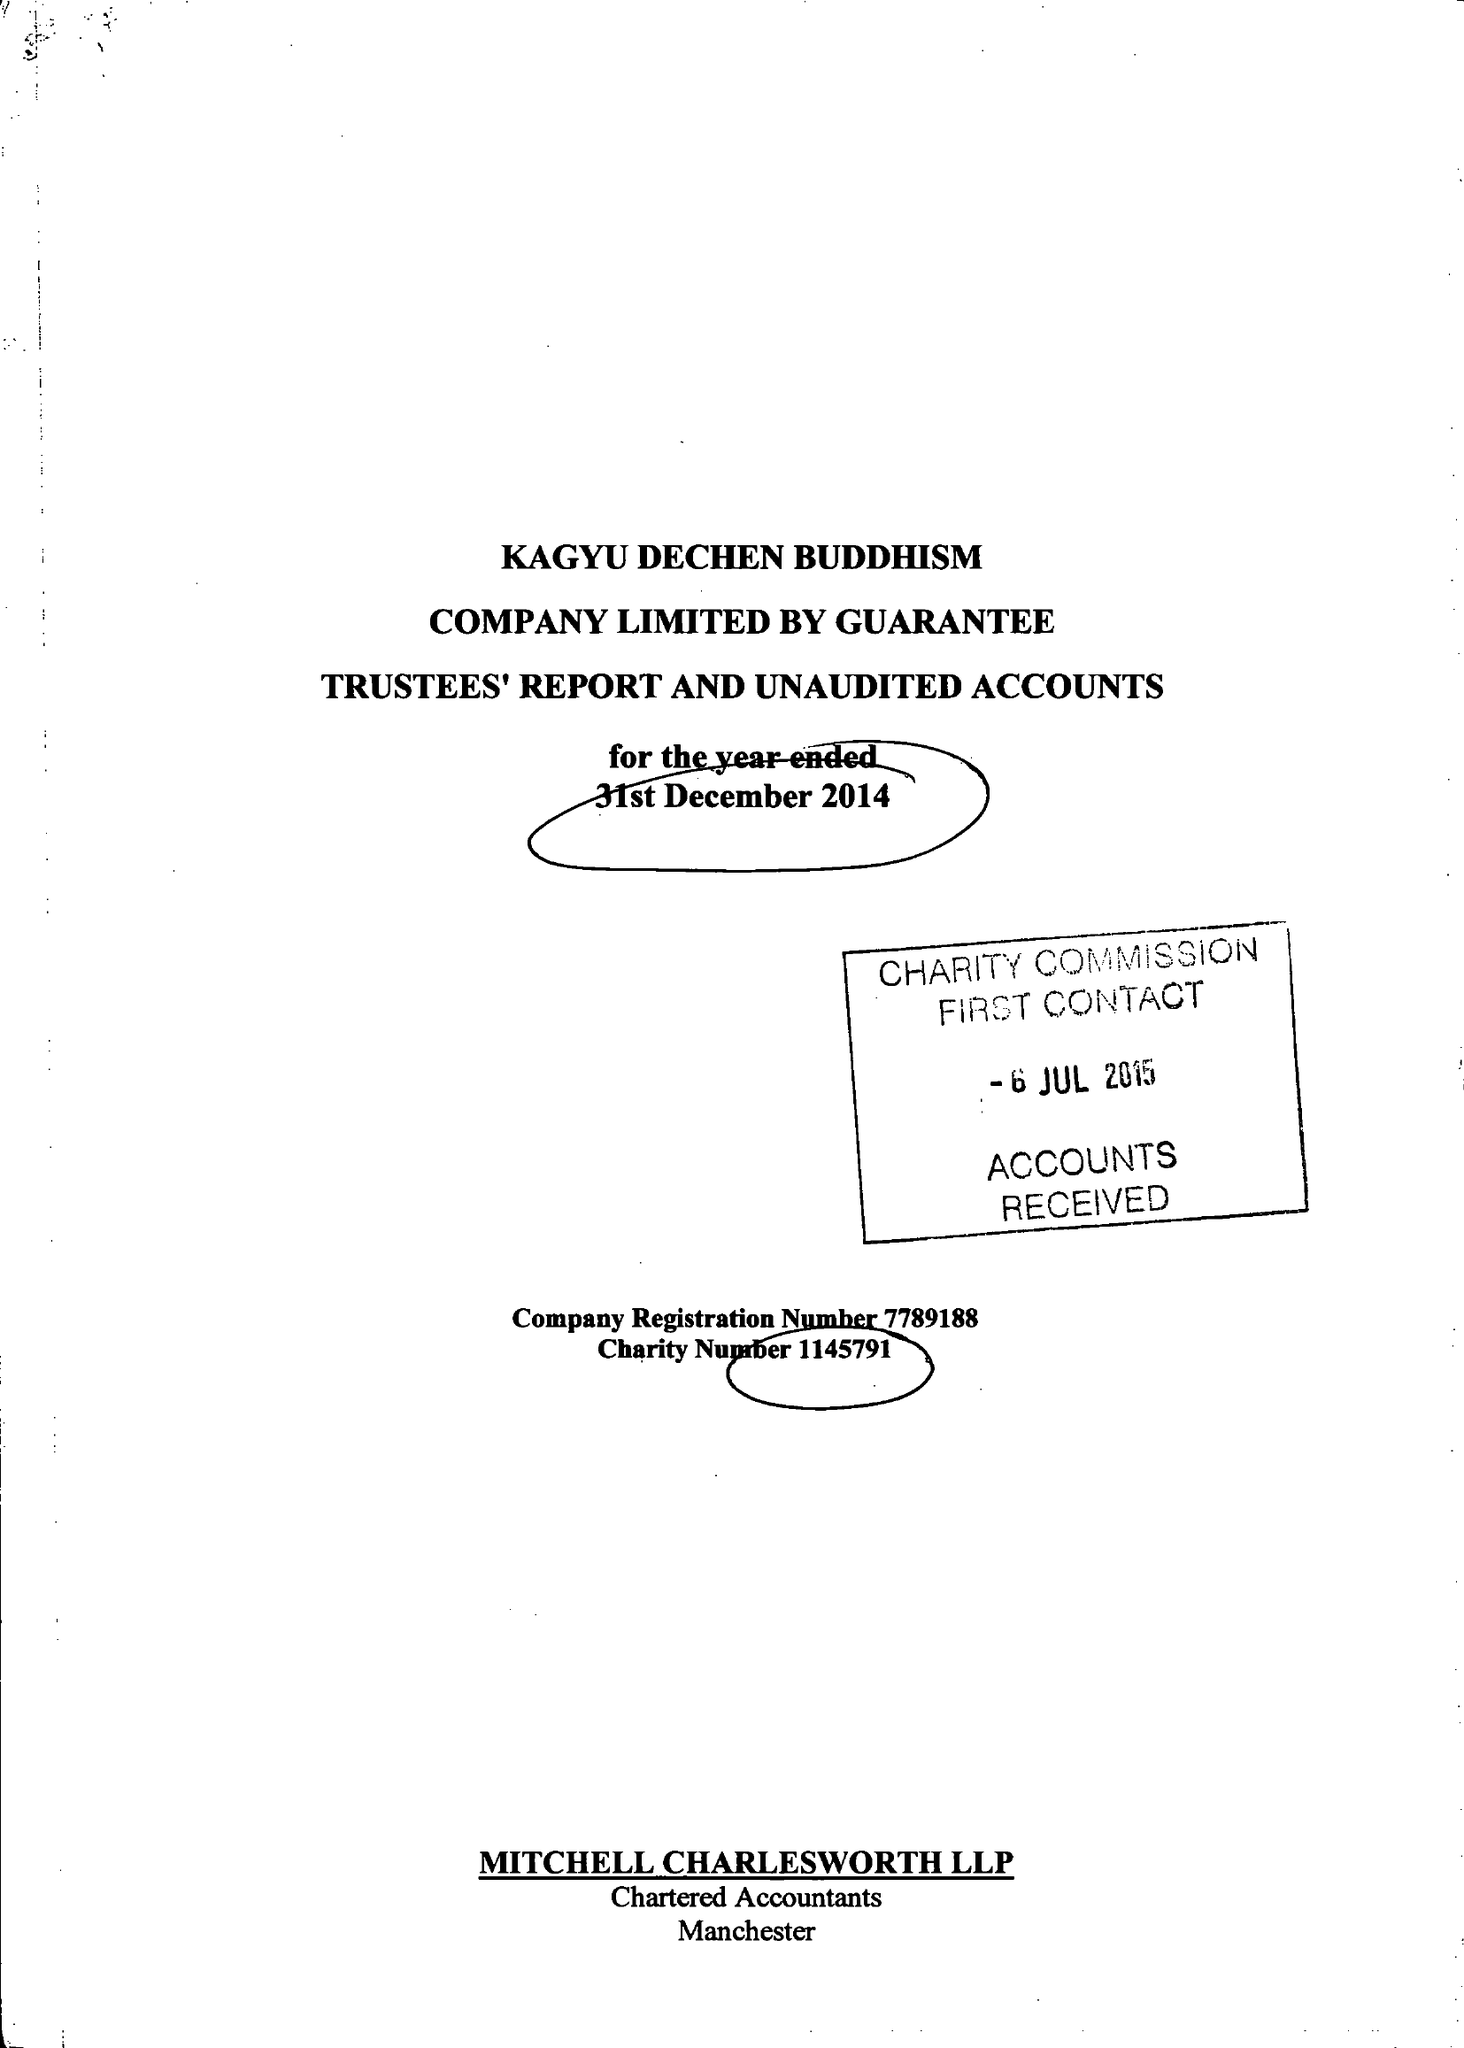What is the value for the address__street_line?
Answer the question using a single word or phrase. 45 MANOR DRIVE 